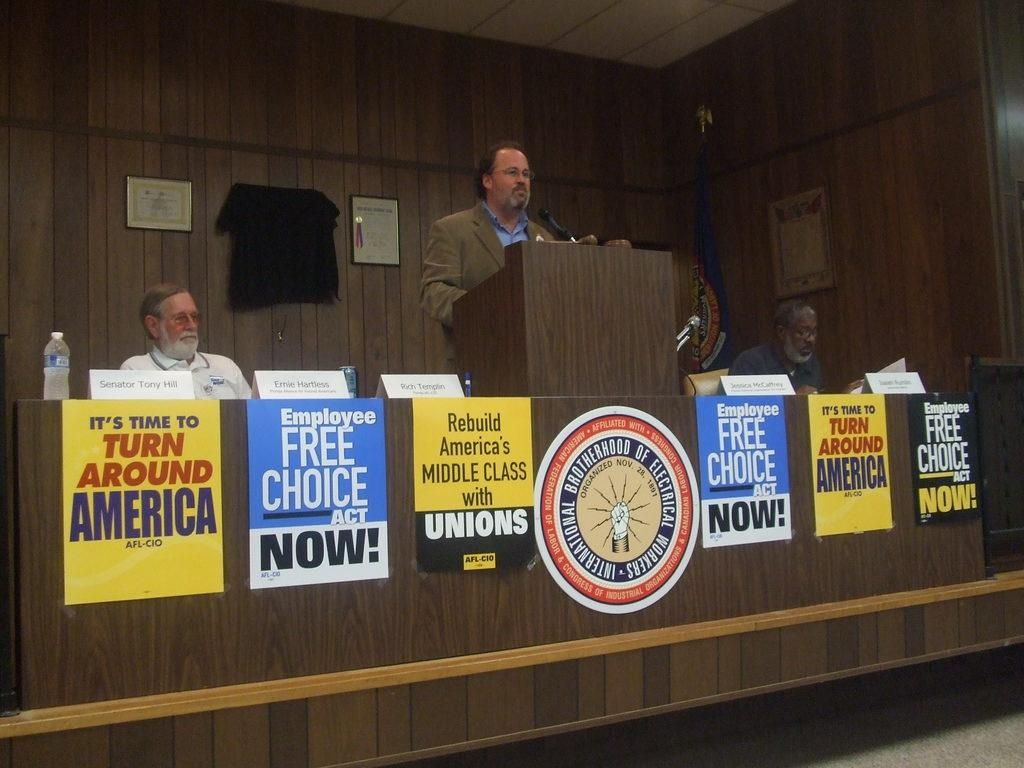Provide a one-sentence caption for the provided image. Campaign posters line a podium where a man speaks at the International Electrician's Brotherhood. 